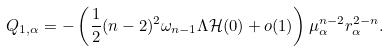Convert formula to latex. <formula><loc_0><loc_0><loc_500><loc_500>Q _ { 1 , \alpha } = - \left ( \frac { 1 } { 2 } { ( n - 2 ) ^ { 2 } } \omega _ { n - 1 } \Lambda \mathcal { H } ( 0 ) + o ( 1 ) \right ) \mu _ { \alpha } ^ { n - 2 } r _ { \alpha } ^ { 2 - n } .</formula> 